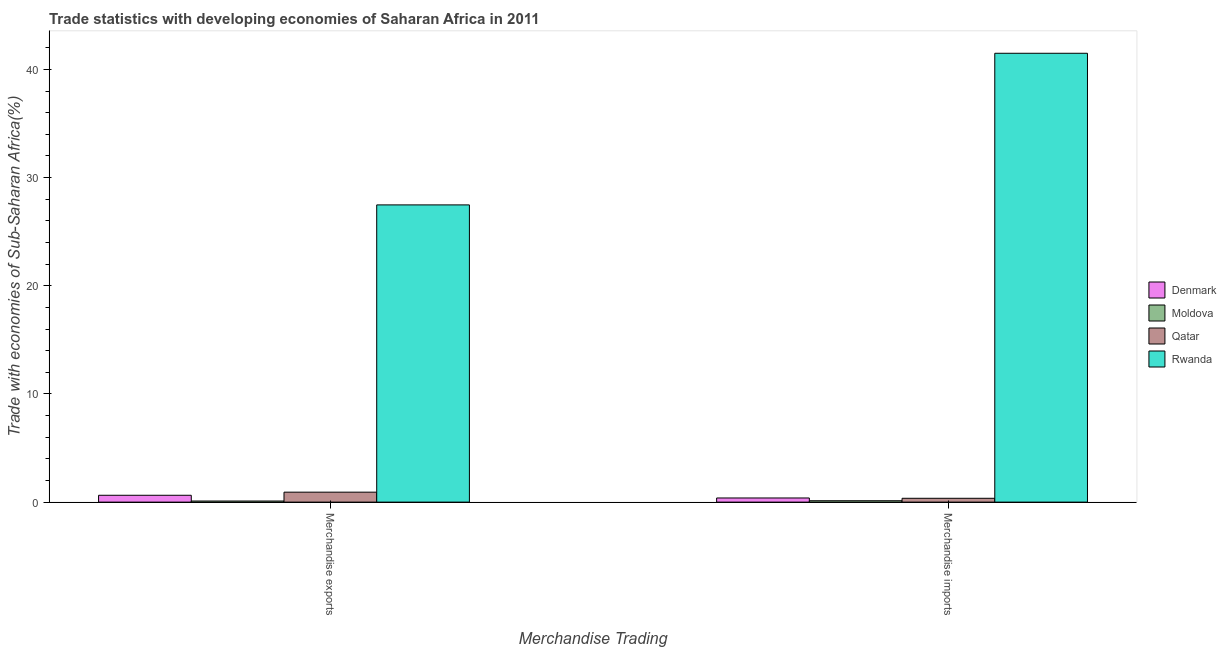How many different coloured bars are there?
Your answer should be very brief. 4. Are the number of bars per tick equal to the number of legend labels?
Your response must be concise. Yes. How many bars are there on the 2nd tick from the left?
Your answer should be compact. 4. What is the merchandise imports in Qatar?
Provide a short and direct response. 0.35. Across all countries, what is the maximum merchandise exports?
Your answer should be compact. 27.47. Across all countries, what is the minimum merchandise exports?
Your answer should be very brief. 0.1. In which country was the merchandise exports maximum?
Provide a succinct answer. Rwanda. In which country was the merchandise exports minimum?
Keep it short and to the point. Moldova. What is the total merchandise imports in the graph?
Provide a short and direct response. 42.36. What is the difference between the merchandise imports in Qatar and that in Rwanda?
Your response must be concise. -41.14. What is the difference between the merchandise exports in Denmark and the merchandise imports in Rwanda?
Keep it short and to the point. -40.86. What is the average merchandise imports per country?
Your response must be concise. 10.59. What is the difference between the merchandise imports and merchandise exports in Qatar?
Give a very brief answer. -0.57. In how many countries, is the merchandise imports greater than 38 %?
Make the answer very short. 1. What is the ratio of the merchandise exports in Moldova to that in Denmark?
Your answer should be very brief. 0.16. In how many countries, is the merchandise imports greater than the average merchandise imports taken over all countries?
Provide a short and direct response. 1. What does the 1st bar from the left in Merchandise exports represents?
Make the answer very short. Denmark. What does the 1st bar from the right in Merchandise imports represents?
Your answer should be compact. Rwanda. How many bars are there?
Your answer should be very brief. 8. Are all the bars in the graph horizontal?
Make the answer very short. No. What is the difference between two consecutive major ticks on the Y-axis?
Keep it short and to the point. 10. Are the values on the major ticks of Y-axis written in scientific E-notation?
Your answer should be compact. No. How many legend labels are there?
Offer a terse response. 4. How are the legend labels stacked?
Offer a very short reply. Vertical. What is the title of the graph?
Your answer should be compact. Trade statistics with developing economies of Saharan Africa in 2011. What is the label or title of the X-axis?
Provide a succinct answer. Merchandise Trading. What is the label or title of the Y-axis?
Your response must be concise. Trade with economies of Sub-Saharan Africa(%). What is the Trade with economies of Sub-Saharan Africa(%) in Denmark in Merchandise exports?
Offer a very short reply. 0.63. What is the Trade with economies of Sub-Saharan Africa(%) of Moldova in Merchandise exports?
Offer a terse response. 0.1. What is the Trade with economies of Sub-Saharan Africa(%) in Qatar in Merchandise exports?
Keep it short and to the point. 0.92. What is the Trade with economies of Sub-Saharan Africa(%) of Rwanda in Merchandise exports?
Make the answer very short. 27.47. What is the Trade with economies of Sub-Saharan Africa(%) in Denmark in Merchandise imports?
Give a very brief answer. 0.38. What is the Trade with economies of Sub-Saharan Africa(%) in Moldova in Merchandise imports?
Provide a short and direct response. 0.13. What is the Trade with economies of Sub-Saharan Africa(%) of Qatar in Merchandise imports?
Ensure brevity in your answer.  0.35. What is the Trade with economies of Sub-Saharan Africa(%) of Rwanda in Merchandise imports?
Your answer should be compact. 41.49. Across all Merchandise Trading, what is the maximum Trade with economies of Sub-Saharan Africa(%) in Denmark?
Ensure brevity in your answer.  0.63. Across all Merchandise Trading, what is the maximum Trade with economies of Sub-Saharan Africa(%) in Moldova?
Your response must be concise. 0.13. Across all Merchandise Trading, what is the maximum Trade with economies of Sub-Saharan Africa(%) of Qatar?
Keep it short and to the point. 0.92. Across all Merchandise Trading, what is the maximum Trade with economies of Sub-Saharan Africa(%) in Rwanda?
Make the answer very short. 41.49. Across all Merchandise Trading, what is the minimum Trade with economies of Sub-Saharan Africa(%) in Denmark?
Provide a succinct answer. 0.38. Across all Merchandise Trading, what is the minimum Trade with economies of Sub-Saharan Africa(%) of Moldova?
Offer a very short reply. 0.1. Across all Merchandise Trading, what is the minimum Trade with economies of Sub-Saharan Africa(%) in Qatar?
Ensure brevity in your answer.  0.35. Across all Merchandise Trading, what is the minimum Trade with economies of Sub-Saharan Africa(%) in Rwanda?
Keep it short and to the point. 27.47. What is the total Trade with economies of Sub-Saharan Africa(%) of Denmark in the graph?
Make the answer very short. 1.02. What is the total Trade with economies of Sub-Saharan Africa(%) in Moldova in the graph?
Ensure brevity in your answer.  0.23. What is the total Trade with economies of Sub-Saharan Africa(%) in Qatar in the graph?
Offer a very short reply. 1.28. What is the total Trade with economies of Sub-Saharan Africa(%) in Rwanda in the graph?
Your response must be concise. 68.96. What is the difference between the Trade with economies of Sub-Saharan Africa(%) in Denmark in Merchandise exports and that in Merchandise imports?
Ensure brevity in your answer.  0.25. What is the difference between the Trade with economies of Sub-Saharan Africa(%) in Moldova in Merchandise exports and that in Merchandise imports?
Offer a very short reply. -0.03. What is the difference between the Trade with economies of Sub-Saharan Africa(%) in Qatar in Merchandise exports and that in Merchandise imports?
Ensure brevity in your answer.  0.57. What is the difference between the Trade with economies of Sub-Saharan Africa(%) of Rwanda in Merchandise exports and that in Merchandise imports?
Your answer should be compact. -14.02. What is the difference between the Trade with economies of Sub-Saharan Africa(%) of Denmark in Merchandise exports and the Trade with economies of Sub-Saharan Africa(%) of Moldova in Merchandise imports?
Ensure brevity in your answer.  0.51. What is the difference between the Trade with economies of Sub-Saharan Africa(%) of Denmark in Merchandise exports and the Trade with economies of Sub-Saharan Africa(%) of Qatar in Merchandise imports?
Provide a short and direct response. 0.28. What is the difference between the Trade with economies of Sub-Saharan Africa(%) of Denmark in Merchandise exports and the Trade with economies of Sub-Saharan Africa(%) of Rwanda in Merchandise imports?
Provide a short and direct response. -40.86. What is the difference between the Trade with economies of Sub-Saharan Africa(%) in Moldova in Merchandise exports and the Trade with economies of Sub-Saharan Africa(%) in Qatar in Merchandise imports?
Your answer should be very brief. -0.25. What is the difference between the Trade with economies of Sub-Saharan Africa(%) of Moldova in Merchandise exports and the Trade with economies of Sub-Saharan Africa(%) of Rwanda in Merchandise imports?
Your answer should be very brief. -41.39. What is the difference between the Trade with economies of Sub-Saharan Africa(%) of Qatar in Merchandise exports and the Trade with economies of Sub-Saharan Africa(%) of Rwanda in Merchandise imports?
Ensure brevity in your answer.  -40.57. What is the average Trade with economies of Sub-Saharan Africa(%) of Denmark per Merchandise Trading?
Your response must be concise. 0.51. What is the average Trade with economies of Sub-Saharan Africa(%) of Moldova per Merchandise Trading?
Make the answer very short. 0.11. What is the average Trade with economies of Sub-Saharan Africa(%) in Qatar per Merchandise Trading?
Give a very brief answer. 0.64. What is the average Trade with economies of Sub-Saharan Africa(%) in Rwanda per Merchandise Trading?
Keep it short and to the point. 34.48. What is the difference between the Trade with economies of Sub-Saharan Africa(%) of Denmark and Trade with economies of Sub-Saharan Africa(%) of Moldova in Merchandise exports?
Keep it short and to the point. 0.53. What is the difference between the Trade with economies of Sub-Saharan Africa(%) of Denmark and Trade with economies of Sub-Saharan Africa(%) of Qatar in Merchandise exports?
Your answer should be very brief. -0.29. What is the difference between the Trade with economies of Sub-Saharan Africa(%) in Denmark and Trade with economies of Sub-Saharan Africa(%) in Rwanda in Merchandise exports?
Ensure brevity in your answer.  -26.84. What is the difference between the Trade with economies of Sub-Saharan Africa(%) of Moldova and Trade with economies of Sub-Saharan Africa(%) of Qatar in Merchandise exports?
Offer a very short reply. -0.82. What is the difference between the Trade with economies of Sub-Saharan Africa(%) of Moldova and Trade with economies of Sub-Saharan Africa(%) of Rwanda in Merchandise exports?
Provide a short and direct response. -27.37. What is the difference between the Trade with economies of Sub-Saharan Africa(%) of Qatar and Trade with economies of Sub-Saharan Africa(%) of Rwanda in Merchandise exports?
Offer a terse response. -26.55. What is the difference between the Trade with economies of Sub-Saharan Africa(%) in Denmark and Trade with economies of Sub-Saharan Africa(%) in Moldova in Merchandise imports?
Provide a short and direct response. 0.26. What is the difference between the Trade with economies of Sub-Saharan Africa(%) in Denmark and Trade with economies of Sub-Saharan Africa(%) in Qatar in Merchandise imports?
Provide a short and direct response. 0.03. What is the difference between the Trade with economies of Sub-Saharan Africa(%) of Denmark and Trade with economies of Sub-Saharan Africa(%) of Rwanda in Merchandise imports?
Provide a short and direct response. -41.11. What is the difference between the Trade with economies of Sub-Saharan Africa(%) of Moldova and Trade with economies of Sub-Saharan Africa(%) of Qatar in Merchandise imports?
Keep it short and to the point. -0.23. What is the difference between the Trade with economies of Sub-Saharan Africa(%) of Moldova and Trade with economies of Sub-Saharan Africa(%) of Rwanda in Merchandise imports?
Offer a very short reply. -41.36. What is the difference between the Trade with economies of Sub-Saharan Africa(%) in Qatar and Trade with economies of Sub-Saharan Africa(%) in Rwanda in Merchandise imports?
Give a very brief answer. -41.14. What is the ratio of the Trade with economies of Sub-Saharan Africa(%) in Denmark in Merchandise exports to that in Merchandise imports?
Offer a very short reply. 1.65. What is the ratio of the Trade with economies of Sub-Saharan Africa(%) in Moldova in Merchandise exports to that in Merchandise imports?
Your response must be concise. 0.8. What is the ratio of the Trade with economies of Sub-Saharan Africa(%) of Qatar in Merchandise exports to that in Merchandise imports?
Your response must be concise. 2.6. What is the ratio of the Trade with economies of Sub-Saharan Africa(%) of Rwanda in Merchandise exports to that in Merchandise imports?
Your answer should be compact. 0.66. What is the difference between the highest and the second highest Trade with economies of Sub-Saharan Africa(%) of Denmark?
Ensure brevity in your answer.  0.25. What is the difference between the highest and the second highest Trade with economies of Sub-Saharan Africa(%) in Moldova?
Keep it short and to the point. 0.03. What is the difference between the highest and the second highest Trade with economies of Sub-Saharan Africa(%) in Qatar?
Your response must be concise. 0.57. What is the difference between the highest and the second highest Trade with economies of Sub-Saharan Africa(%) of Rwanda?
Offer a very short reply. 14.02. What is the difference between the highest and the lowest Trade with economies of Sub-Saharan Africa(%) in Denmark?
Ensure brevity in your answer.  0.25. What is the difference between the highest and the lowest Trade with economies of Sub-Saharan Africa(%) in Moldova?
Provide a short and direct response. 0.03. What is the difference between the highest and the lowest Trade with economies of Sub-Saharan Africa(%) in Qatar?
Give a very brief answer. 0.57. What is the difference between the highest and the lowest Trade with economies of Sub-Saharan Africa(%) of Rwanda?
Your answer should be very brief. 14.02. 